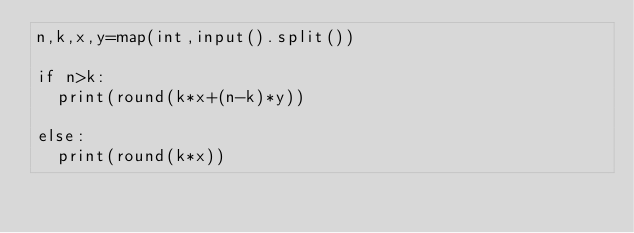<code> <loc_0><loc_0><loc_500><loc_500><_Python_>n,k,x,y=map(int,input().split())

if n>k:
  print(round(k*x+(n-k)*y))

else:
  print(round(k*x))
      </code> 